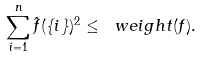<formula> <loc_0><loc_0><loc_500><loc_500>\sum _ { i = 1 } ^ { n } \hat { f } ( \{ i \} ) ^ { 2 } \leq \ w e i g h t ( f ) .</formula> 